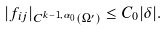Convert formula to latex. <formula><loc_0><loc_0><loc_500><loc_500>| f _ { i j } | _ { C ^ { k - 1 , \alpha _ { 0 } } ( \Omega ^ { \prime } ) } \leq C _ { 0 } | \delta | .</formula> 